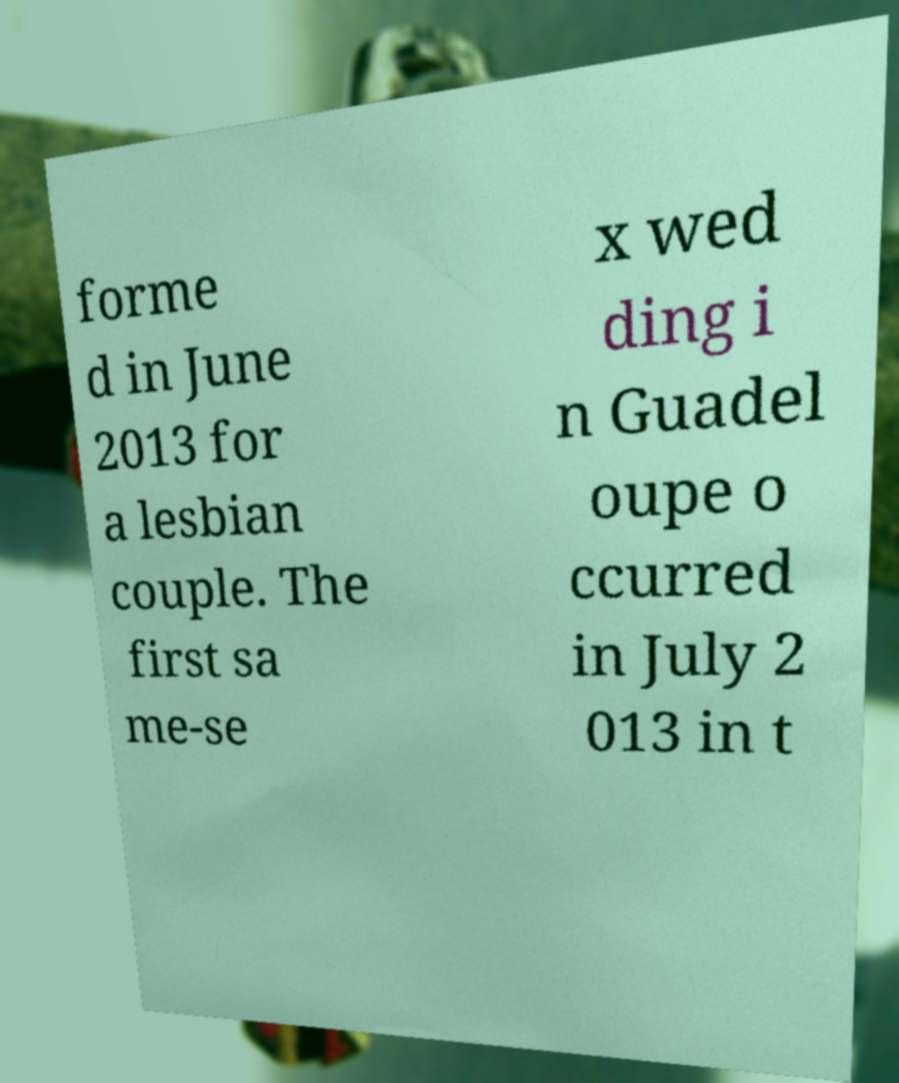Please identify and transcribe the text found in this image. forme d in June 2013 for a lesbian couple. The first sa me-se x wed ding i n Guadel oupe o ccurred in July 2 013 in t 